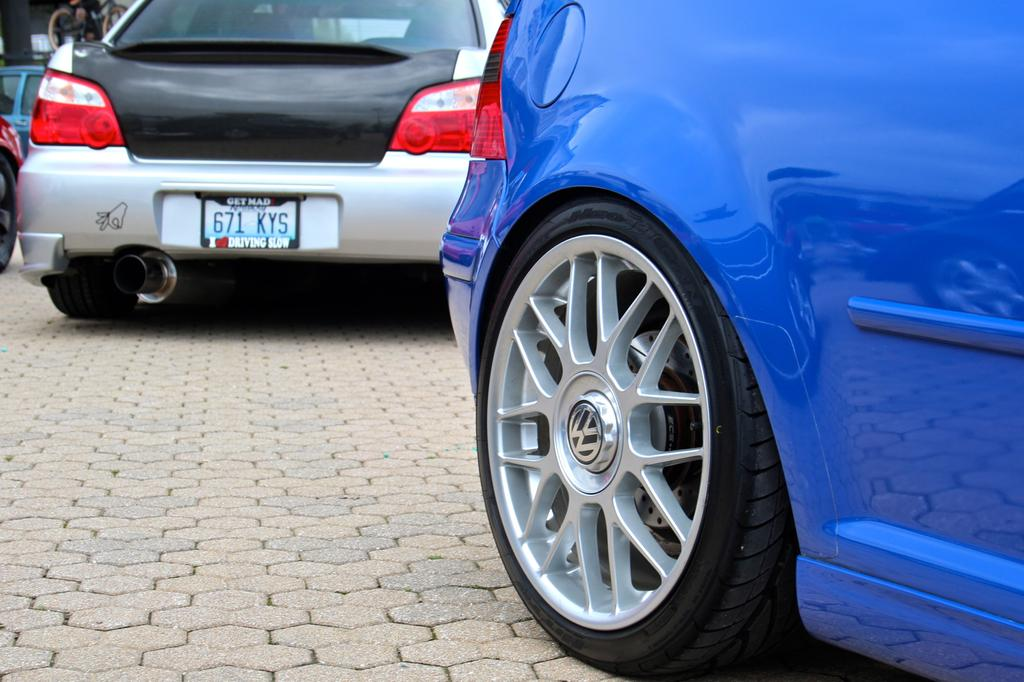What is located in the foreground of the image? There is a platform in the foreground of the image. What type of vehicle is on the platform? A blue color car is on the platform. What additional object can be seen on the platform? A tire is present on the platform. What can be seen at the top of the image? There is a black and silver color car visible at the top of the image. Where is the stove located in the image? There is no stove present in the image. Can you describe the office setting in the image? There is no office setting present in the image. 